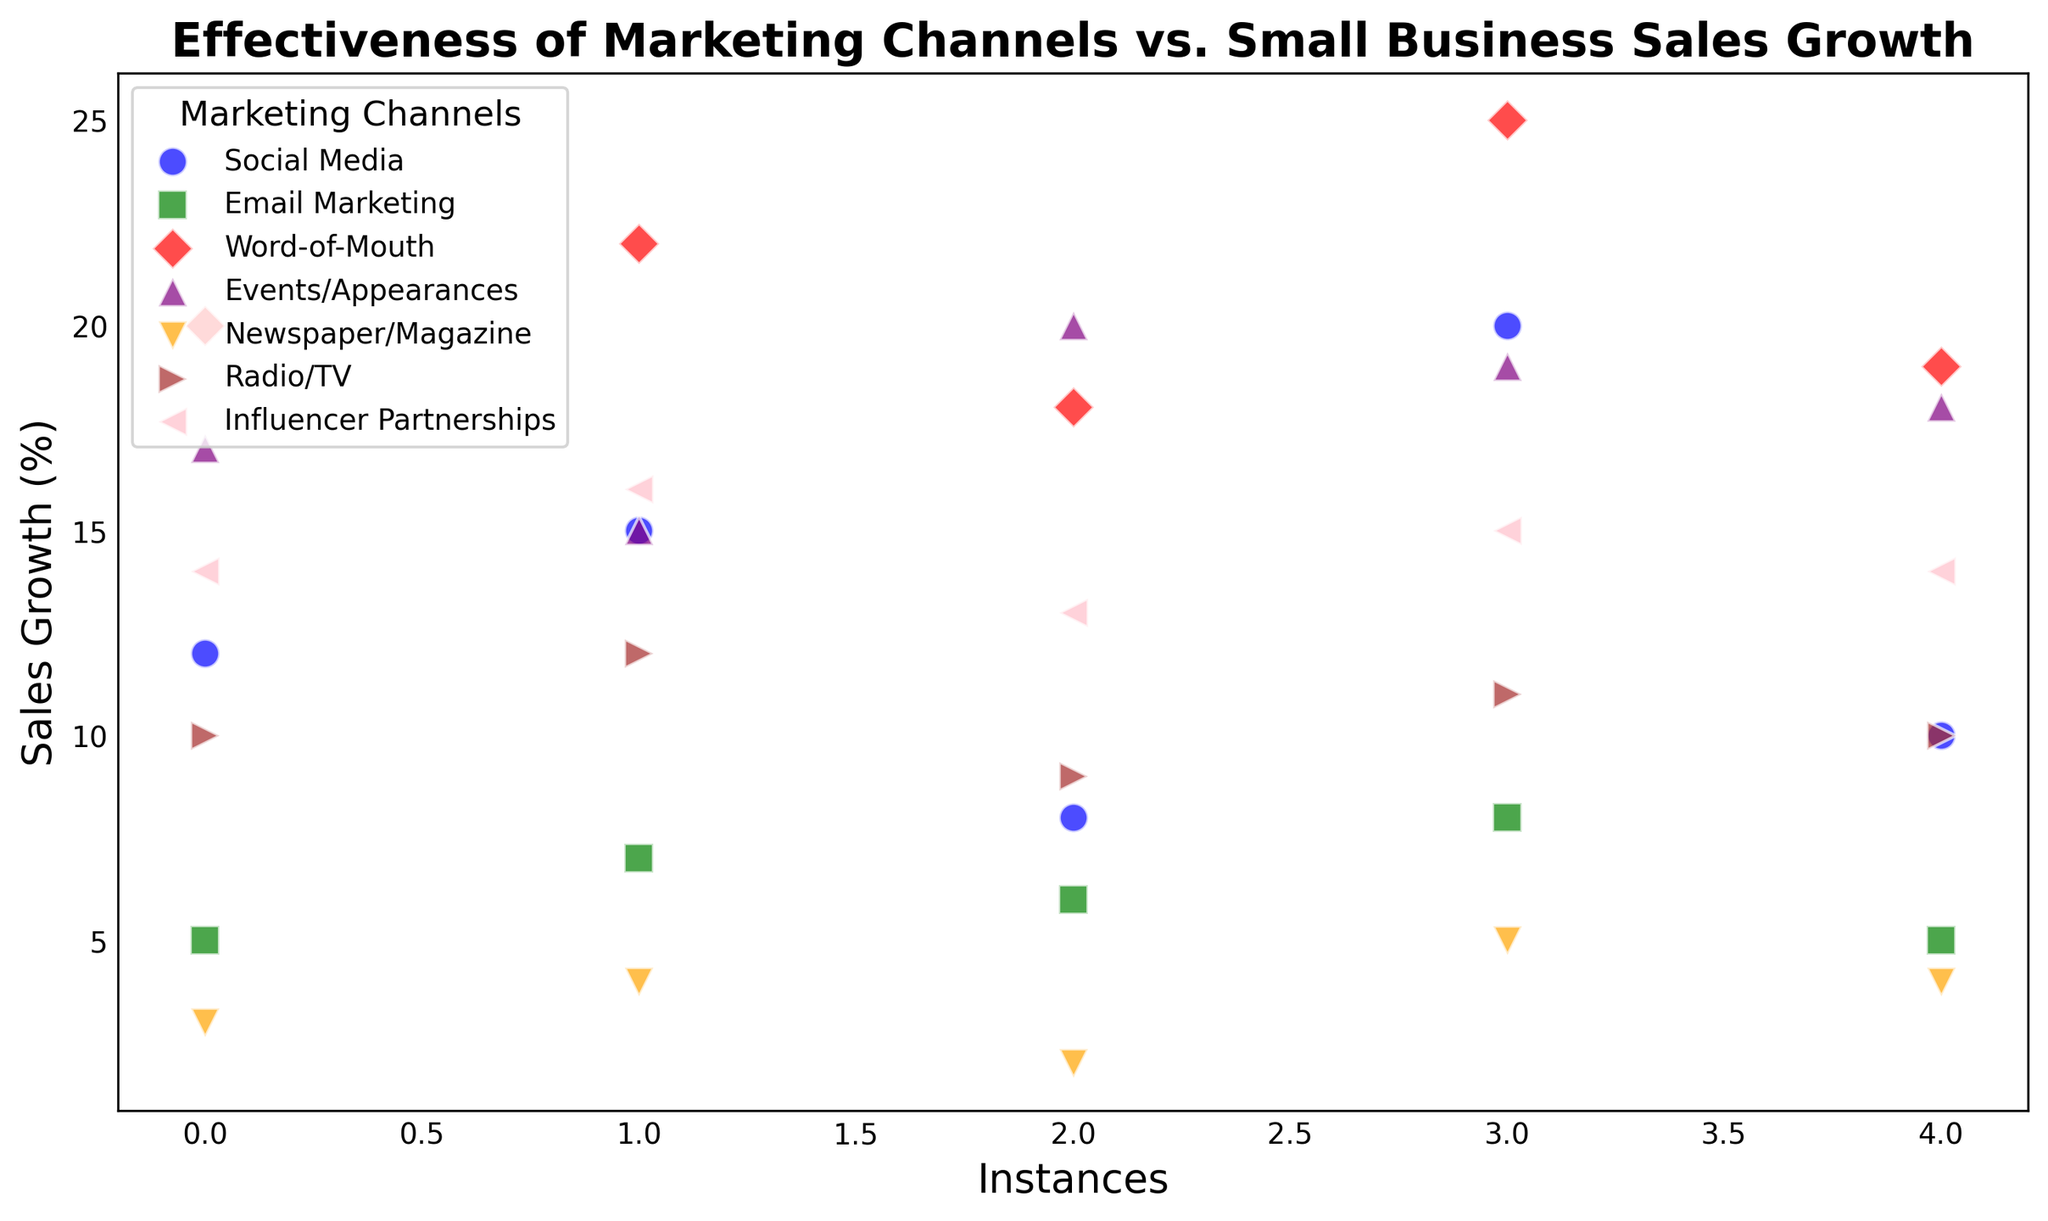what marketing channel has the highest sales growth values? Observing the heights of the data points, the highest cluster corresponds to the red markers, which represent the Word-of-Mouth channel with sales growth values between 18 and 25 percent.
Answer: Word-of-Mouth what marketing channel has the lowest average sales growth? By visually comparing the clusters, the orange markers representing Newspaper/Magazine have the lowest sales growth values between 2 and 5 percent. Calculating the average of these values (3+4+2+5+4)/5, we find it is 3.6 percent, which is lower than other channels.
Answer: Newspaper/Magazine how does Radio/TV compare to Influencer Partnerships in terms of sales growth? The brown markers for Radio/TV have growth values between 9 and 12 percent, while the pink markers for Influencer Partnerships have values between 13 and 16 percent. Thus, Influencer Partnerships have a generally higher sales growth than Radio/TV.
Answer: Influencer Partnerships has higher sales growth what is the range of sales growth values for Social Media? The blue markers for Social Media show values ranging from 8 to 20 percent. The range is calculated as 20 - 8 = 12 percent.
Answer: 12 percent which marketing channel has the most consistent sales growth values? By looking for the channel with the least spread in vertical height, the green markers for Email Marketing are tightly clustered between 5 and 8 percent, showing the most consistency.
Answer: Email Marketing what is the combined average sales growth of Events/Appearances and Social Media channels? First, calculate the individual averages: Events/Appearances (17+15+20+19+18) / 5 = 17.8 percent, and Social Media (12+15+8+20+10) / 5 = 13 percent. Adding these gives 17.8 + 13 = 30.8, and dividing by 2 results in an average of 15.4 percent.
Answer: 15.4 percent how many marketing channels have at least one data point above 15 percent sales growth? By visually checking each cluster, Social Media, Word-of-Mouth, Events/Appearances, Radio/TV, and Influencer Partnerships have at least one point above 15 percent. Email Marketing and Newspaper/Magazine do not.
Answer: 5 channels which has a lower highest sales growth value, Radio/TV or Email Marketing? The highest sales growth for Radio/TV, represented by brown markers, is 12 percent, while for Email Marketing, represented by green markers, it is 8 percent, showing Email Marketing has a lower highest value.
Answer: Email Marketing 